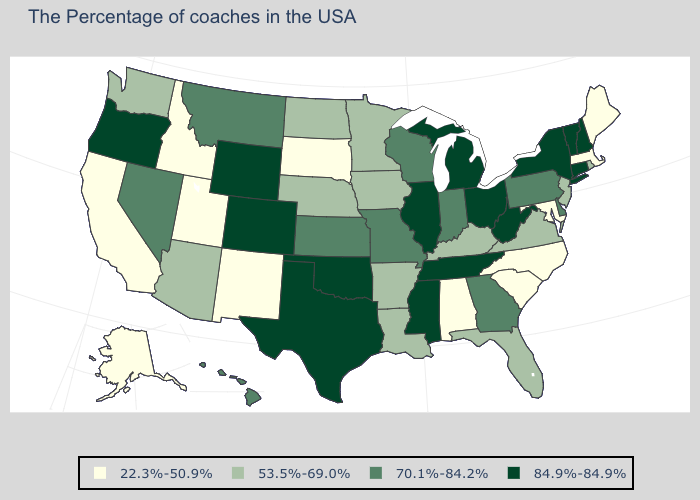What is the lowest value in the USA?
Concise answer only. 22.3%-50.9%. Which states have the highest value in the USA?
Concise answer only. New Hampshire, Vermont, Connecticut, New York, West Virginia, Ohio, Michigan, Tennessee, Illinois, Mississippi, Oklahoma, Texas, Wyoming, Colorado, Oregon. What is the value of California?
Quick response, please. 22.3%-50.9%. What is the lowest value in states that border South Carolina?
Quick response, please. 22.3%-50.9%. What is the value of Illinois?
Keep it brief. 84.9%-84.9%. Which states have the highest value in the USA?
Keep it brief. New Hampshire, Vermont, Connecticut, New York, West Virginia, Ohio, Michigan, Tennessee, Illinois, Mississippi, Oklahoma, Texas, Wyoming, Colorado, Oregon. Name the states that have a value in the range 84.9%-84.9%?
Write a very short answer. New Hampshire, Vermont, Connecticut, New York, West Virginia, Ohio, Michigan, Tennessee, Illinois, Mississippi, Oklahoma, Texas, Wyoming, Colorado, Oregon. Among the states that border Missouri , which have the highest value?
Be succinct. Tennessee, Illinois, Oklahoma. What is the value of Virginia?
Keep it brief. 53.5%-69.0%. Name the states that have a value in the range 53.5%-69.0%?
Short answer required. Rhode Island, New Jersey, Virginia, Florida, Kentucky, Louisiana, Arkansas, Minnesota, Iowa, Nebraska, North Dakota, Arizona, Washington. How many symbols are there in the legend?
Concise answer only. 4. How many symbols are there in the legend?
Concise answer only. 4. What is the value of South Carolina?
Short answer required. 22.3%-50.9%. Name the states that have a value in the range 22.3%-50.9%?
Write a very short answer. Maine, Massachusetts, Maryland, North Carolina, South Carolina, Alabama, South Dakota, New Mexico, Utah, Idaho, California, Alaska. Name the states that have a value in the range 53.5%-69.0%?
Answer briefly. Rhode Island, New Jersey, Virginia, Florida, Kentucky, Louisiana, Arkansas, Minnesota, Iowa, Nebraska, North Dakota, Arizona, Washington. 